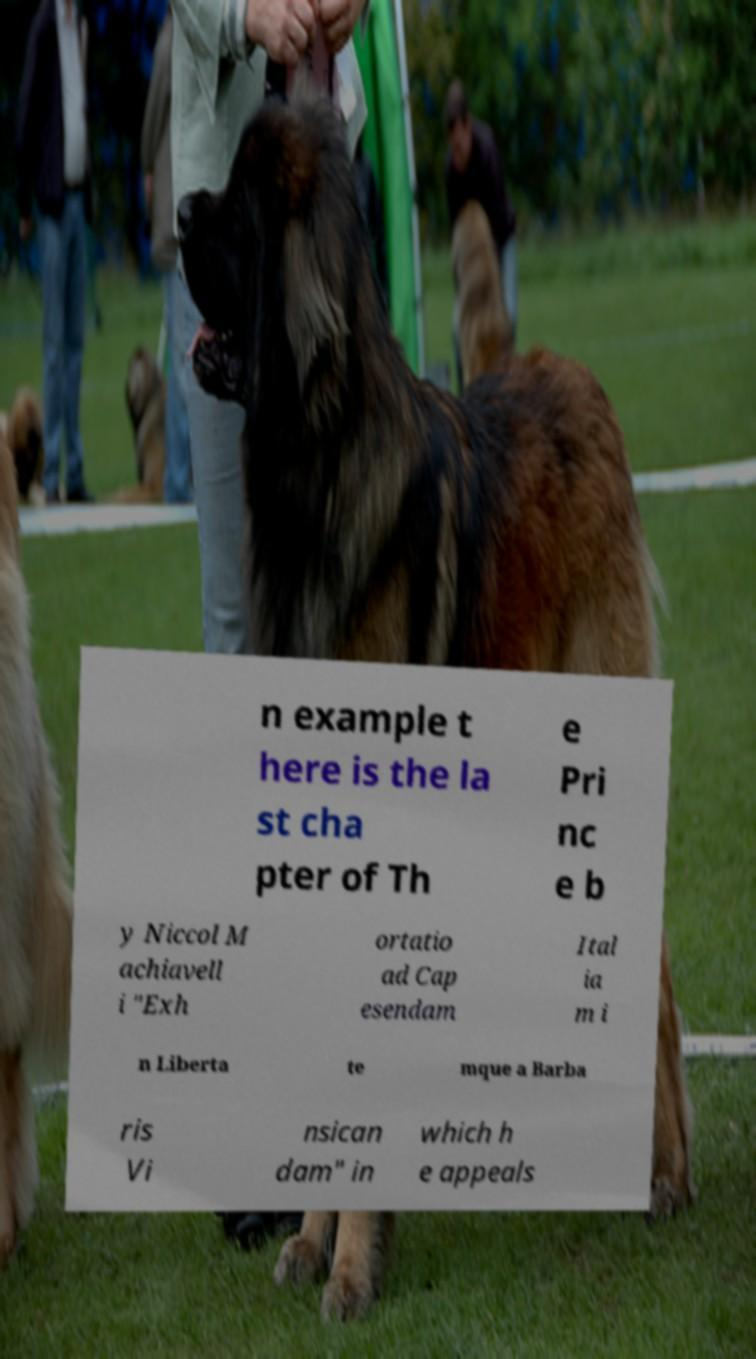Could you extract and type out the text from this image? n example t here is the la st cha pter of Th e Pri nc e b y Niccol M achiavell i "Exh ortatio ad Cap esendam Ital ia m i n Liberta te mque a Barba ris Vi nsican dam" in which h e appeals 